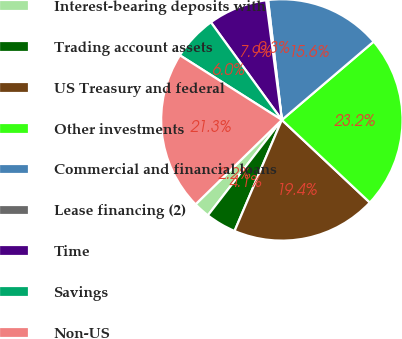<chart> <loc_0><loc_0><loc_500><loc_500><pie_chart><fcel>Interest-bearing deposits with<fcel>Trading account assets<fcel>US Treasury and federal<fcel>Other investments<fcel>Commercial and financial loans<fcel>Lease financing (2)<fcel>Time<fcel>Savings<fcel>Non-US<nl><fcel>2.18%<fcel>4.09%<fcel>19.41%<fcel>23.24%<fcel>15.58%<fcel>0.26%<fcel>7.92%<fcel>6.01%<fcel>21.32%<nl></chart> 